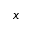Convert formula to latex. <formula><loc_0><loc_0><loc_500><loc_500>x</formula> 